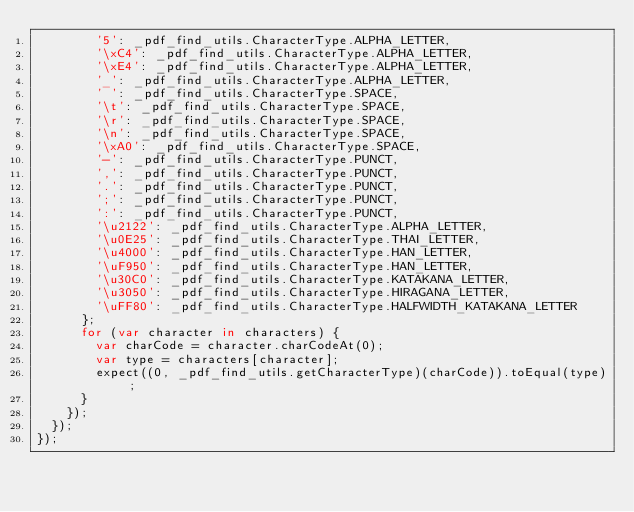<code> <loc_0><loc_0><loc_500><loc_500><_JavaScript_>        '5': _pdf_find_utils.CharacterType.ALPHA_LETTER,
        '\xC4': _pdf_find_utils.CharacterType.ALPHA_LETTER,
        '\xE4': _pdf_find_utils.CharacterType.ALPHA_LETTER,
        '_': _pdf_find_utils.CharacterType.ALPHA_LETTER,
        ' ': _pdf_find_utils.CharacterType.SPACE,
        '\t': _pdf_find_utils.CharacterType.SPACE,
        '\r': _pdf_find_utils.CharacterType.SPACE,
        '\n': _pdf_find_utils.CharacterType.SPACE,
        '\xA0': _pdf_find_utils.CharacterType.SPACE,
        '-': _pdf_find_utils.CharacterType.PUNCT,
        ',': _pdf_find_utils.CharacterType.PUNCT,
        '.': _pdf_find_utils.CharacterType.PUNCT,
        ';': _pdf_find_utils.CharacterType.PUNCT,
        ':': _pdf_find_utils.CharacterType.PUNCT,
        '\u2122': _pdf_find_utils.CharacterType.ALPHA_LETTER,
        '\u0E25': _pdf_find_utils.CharacterType.THAI_LETTER,
        '\u4000': _pdf_find_utils.CharacterType.HAN_LETTER,
        '\uF950': _pdf_find_utils.CharacterType.HAN_LETTER,
        '\u30C0': _pdf_find_utils.CharacterType.KATAKANA_LETTER,
        '\u3050': _pdf_find_utils.CharacterType.HIRAGANA_LETTER,
        '\uFF80': _pdf_find_utils.CharacterType.HALFWIDTH_KATAKANA_LETTER
      };
      for (var character in characters) {
        var charCode = character.charCodeAt(0);
        var type = characters[character];
        expect((0, _pdf_find_utils.getCharacterType)(charCode)).toEqual(type);
      }
    });
  });
});</code> 